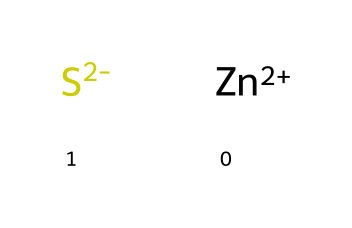how many atoms are in this structure? The structure contains two different elements: Zinc (Zn) and Sulfur (S). The representation [Zn+2] indicates one Zinc atom, and [S-2] indicates one Sulfur atom. Therefore, there are a total of two atoms in the structure.
Answer: two what is the charge on the sulfur atom? The notation [S-2] indicates that the sulfur atom has a charge of -2. The negative sign indicates the electron gain that leads to this charge.
Answer: -2 how many types of ion are present? The chemical representation shows two distinct ions: Zinc (Zn) and Sulfur (S), since it includes one cation (Zn+2) and one anion (S-2). This categorization extends the notion of types to both positive and negative ions.
Answer: two what type of bond is expected between the zinc and sulfur atoms? Given that Zinc (Zn) has a +2 charge and Sulfur (S) has a -2 charge, they are expected to form an ionic bond due to the electrostatic attraction between the oppositely charged ions.
Answer: ionic why is this chemical used as a fluorescent dye? The compound forms a fluorescent dye due in large part to the interactions between the Zinc atom and the Sulfur atom, as ionic structures can facilitate electron transitions which are integral for fluorescence. The energy from these transitions results in the emission of light.
Answer: electron transitions how does this structure relate to glow-in-the-dark properties? The presence of Zinc in this chemical structure allows it to absorb energy and subsequently release it as visible light when activated. The ionic bond created by the charges also contributes to trapping and releasing energy efficiently.
Answer: absorbs energy 